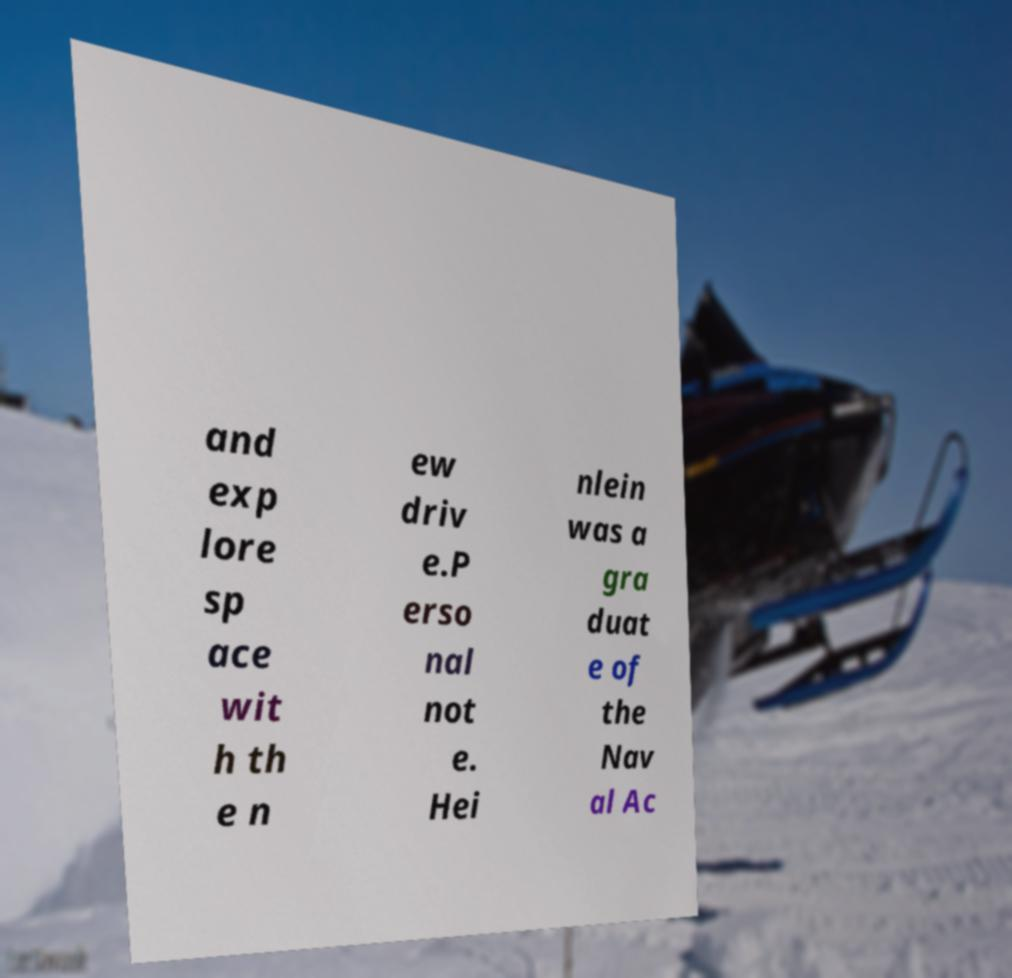For documentation purposes, I need the text within this image transcribed. Could you provide that? and exp lore sp ace wit h th e n ew driv e.P erso nal not e. Hei nlein was a gra duat e of the Nav al Ac 